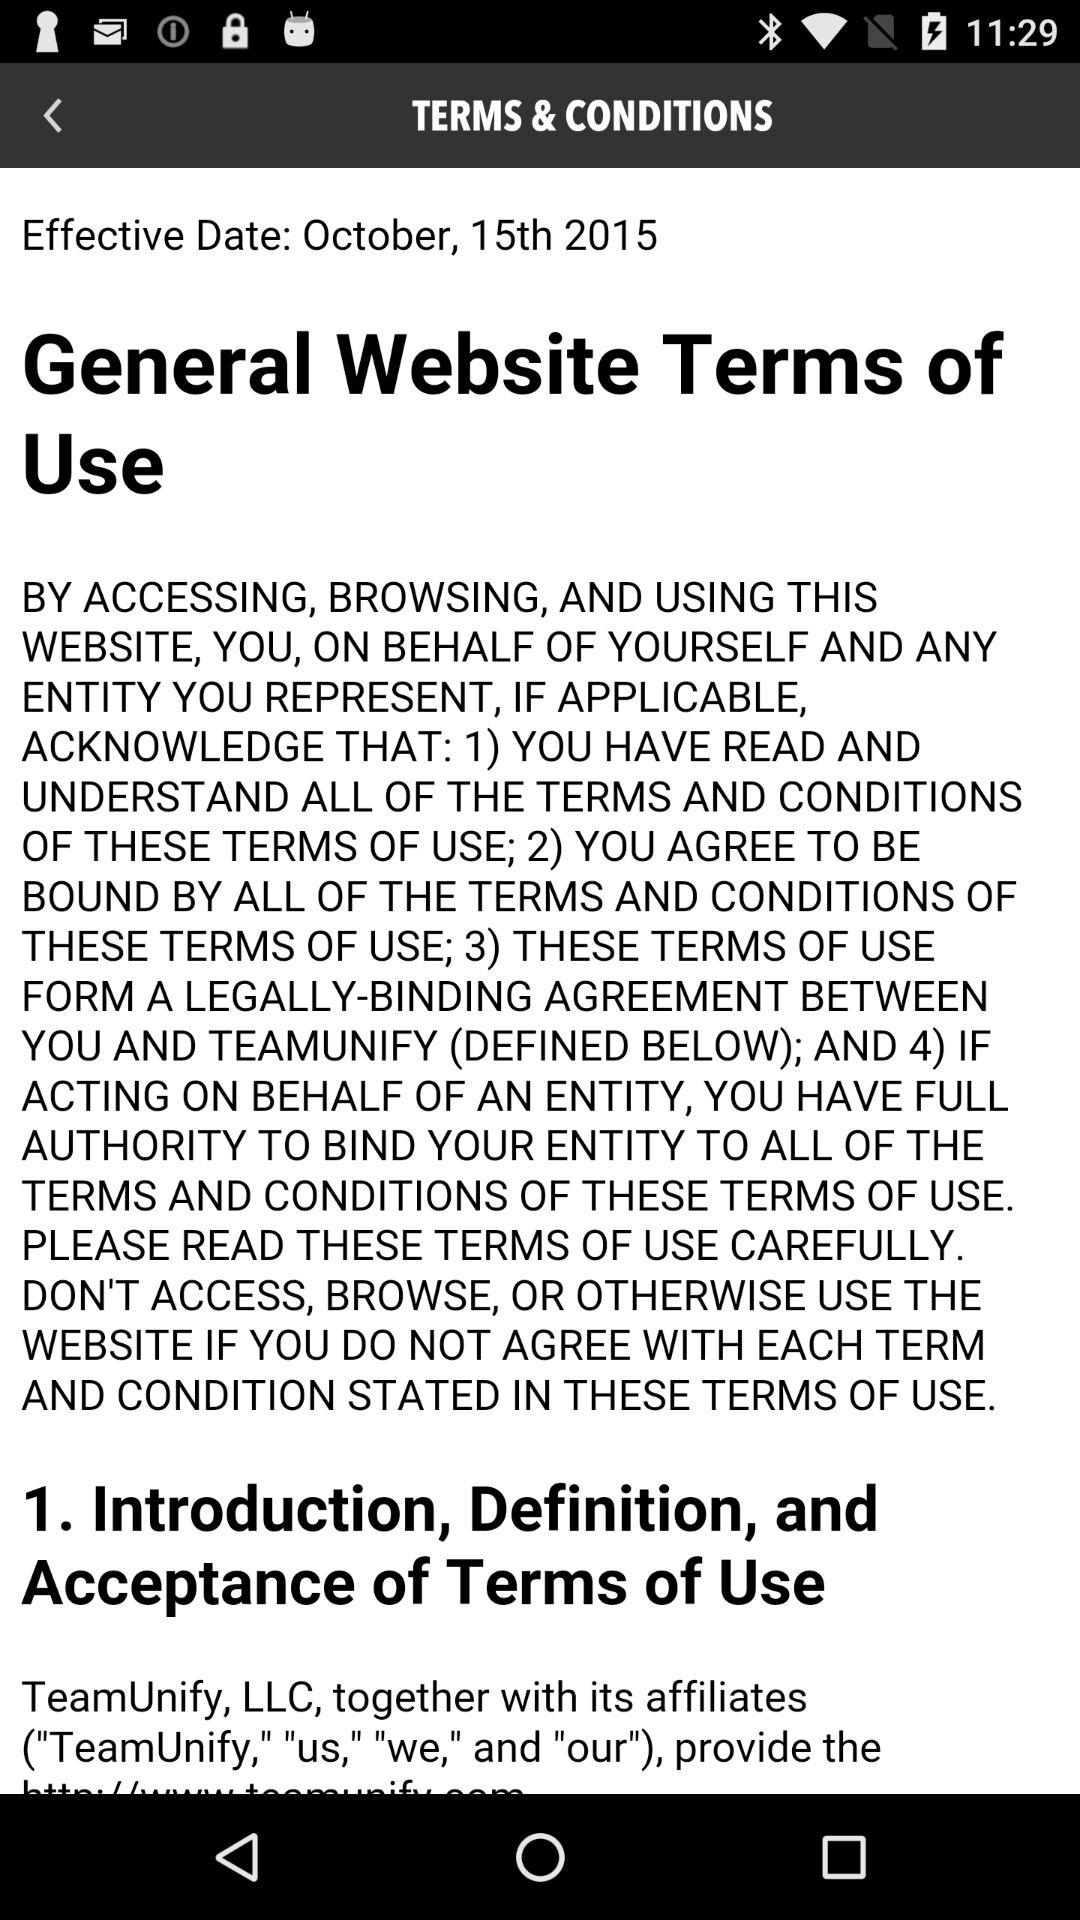What is the date? The date is October 15, 2015. 